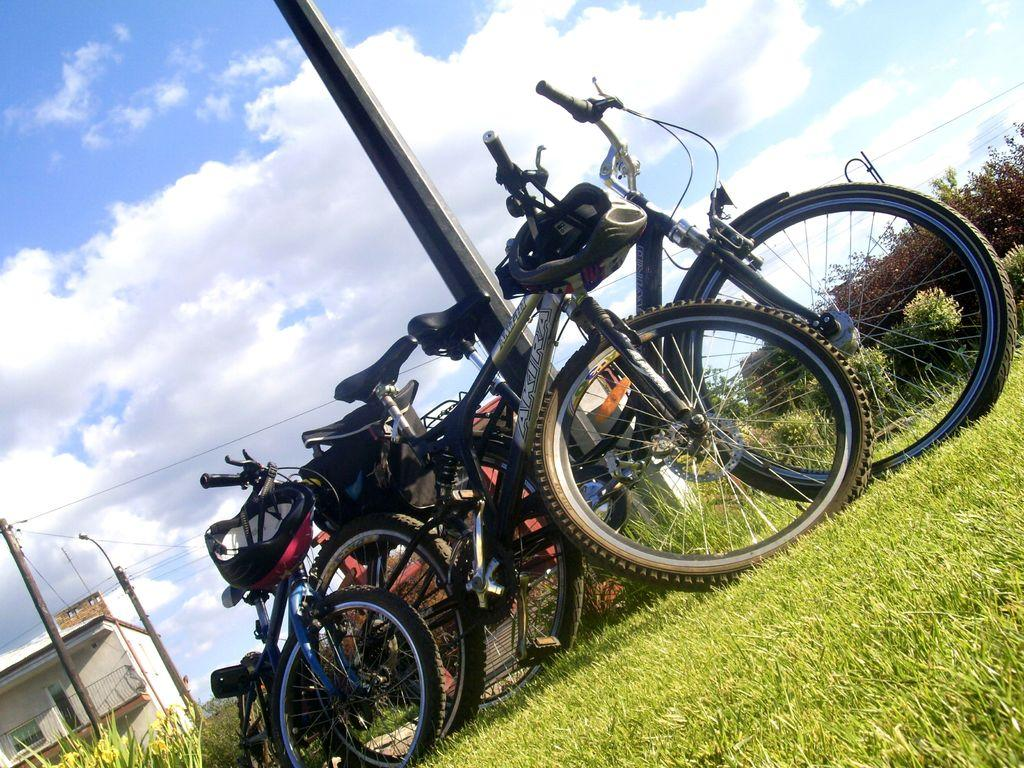What type of vehicles are present in the image? There are many bicycles in the image. What safety equipment can be seen in the image? There is a helmet in the image. What type of terrain is visible in the image? There is grass in the image. What type of structure is present in the image? There is a pole in the image. What type of pole is present in the image? There is an electric pole in the image. What is connected to the electric pole in the image? There are electric wires in the image. What type of plant is present in the image? There is a plant in the image. What type of man-made structure is present in the image? There is a building in the image. What is the weather like in the image? The sky is cloudy in the image. Can you tell me how many boys are holding the canvas in the image? There is no canvas or boy present in the image. What type of shock can be seen coming from the electric wires in the image? There is no shock present in the image; the electric wires are simply connected to the electric pole. 